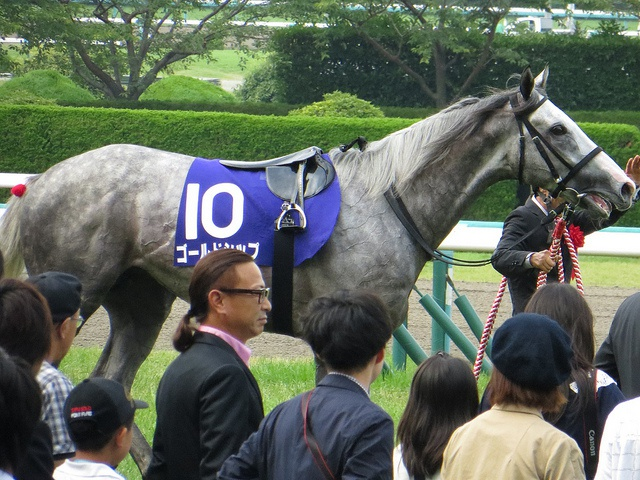Describe the objects in this image and their specific colors. I can see horse in darkgreen, gray, black, darkgray, and lightgray tones, people in darkgreen, black, gray, and darkblue tones, people in darkgreen, black, gray, and maroon tones, people in darkgreen, black, tan, beige, and navy tones, and people in darkgreen, black, gray, and maroon tones in this image. 